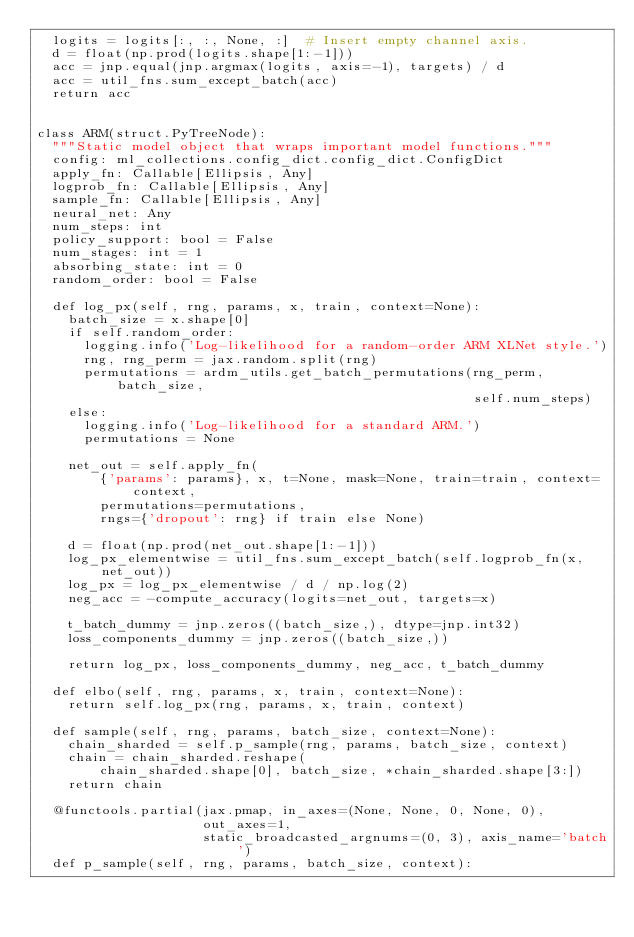Convert code to text. <code><loc_0><loc_0><loc_500><loc_500><_Python_>  logits = logits[:, :, None, :]  # Insert empty channel axis.
  d = float(np.prod(logits.shape[1:-1]))
  acc = jnp.equal(jnp.argmax(logits, axis=-1), targets) / d
  acc = util_fns.sum_except_batch(acc)
  return acc


class ARM(struct.PyTreeNode):
  """Static model object that wraps important model functions."""
  config: ml_collections.config_dict.config_dict.ConfigDict
  apply_fn: Callable[Ellipsis, Any]
  logprob_fn: Callable[Ellipsis, Any]
  sample_fn: Callable[Ellipsis, Any]
  neural_net: Any
  num_steps: int
  policy_support: bool = False
  num_stages: int = 1
  absorbing_state: int = 0
  random_order: bool = False

  def log_px(self, rng, params, x, train, context=None):
    batch_size = x.shape[0]
    if self.random_order:
      logging.info('Log-likelihood for a random-order ARM XLNet style.')
      rng, rng_perm = jax.random.split(rng)
      permutations = ardm_utils.get_batch_permutations(rng_perm, batch_size,
                                                       self.num_steps)
    else:
      logging.info('Log-likelihood for a standard ARM.')
      permutations = None

    net_out = self.apply_fn(
        {'params': params}, x, t=None, mask=None, train=train, context=context,
        permutations=permutations,
        rngs={'dropout': rng} if train else None)

    d = float(np.prod(net_out.shape[1:-1]))
    log_px_elementwise = util_fns.sum_except_batch(self.logprob_fn(x, net_out))
    log_px = log_px_elementwise / d / np.log(2)
    neg_acc = -compute_accuracy(logits=net_out, targets=x)

    t_batch_dummy = jnp.zeros((batch_size,), dtype=jnp.int32)
    loss_components_dummy = jnp.zeros((batch_size,))

    return log_px, loss_components_dummy, neg_acc, t_batch_dummy

  def elbo(self, rng, params, x, train, context=None):
    return self.log_px(rng, params, x, train, context)

  def sample(self, rng, params, batch_size, context=None):
    chain_sharded = self.p_sample(rng, params, batch_size, context)
    chain = chain_sharded.reshape(
        chain_sharded.shape[0], batch_size, *chain_sharded.shape[3:])
    return chain

  @functools.partial(jax.pmap, in_axes=(None, None, 0, None, 0),
                     out_axes=1,
                     static_broadcasted_argnums=(0, 3), axis_name='batch')
  def p_sample(self, rng, params, batch_size, context):</code> 